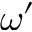Convert formula to latex. <formula><loc_0><loc_0><loc_500><loc_500>\omega ^ { \prime }</formula> 